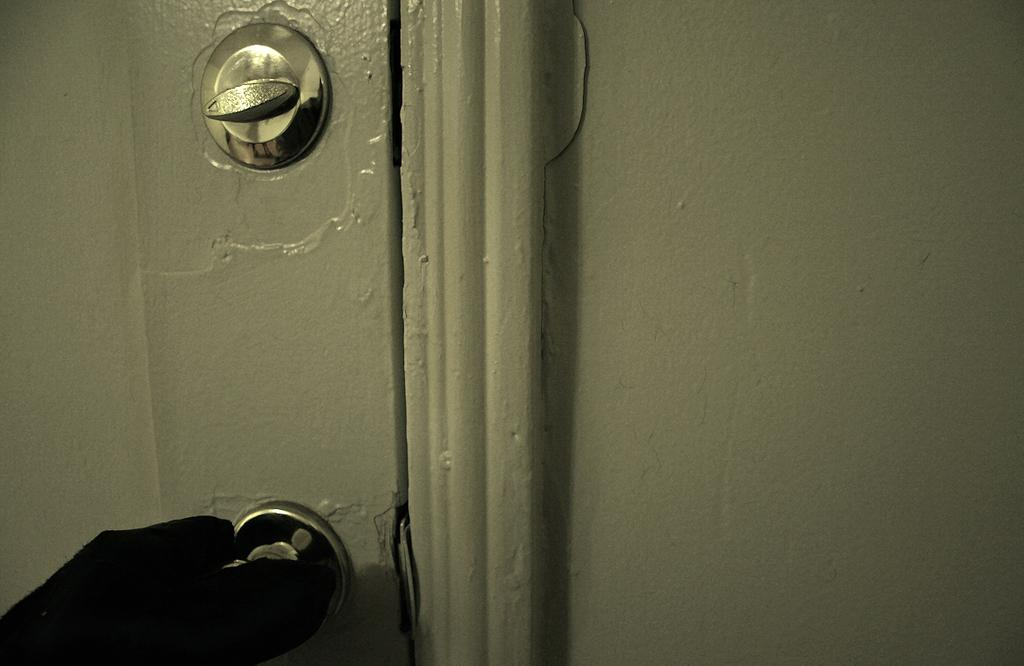What type of objects can be seen in the image? There are door handles in the image. Can you describe the function of these objects? Door handles are used to open and close doors. Are there any other similar objects in the image? The provided facts do not mention any other similar objects. What type of attraction is located near the door handles in the image? There is no information about any attractions in the image; it only features door handles. 